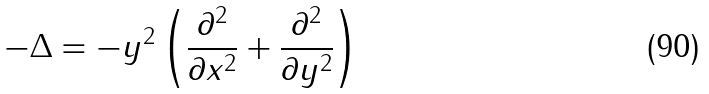Convert formula to latex. <formula><loc_0><loc_0><loc_500><loc_500>- \Delta = - y ^ { 2 } \left ( \frac { \partial ^ { 2 } } { \partial x ^ { 2 } } + \frac { \partial ^ { 2 } } { \partial y ^ { 2 } } \right )</formula> 